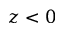<formula> <loc_0><loc_0><loc_500><loc_500>z < 0</formula> 